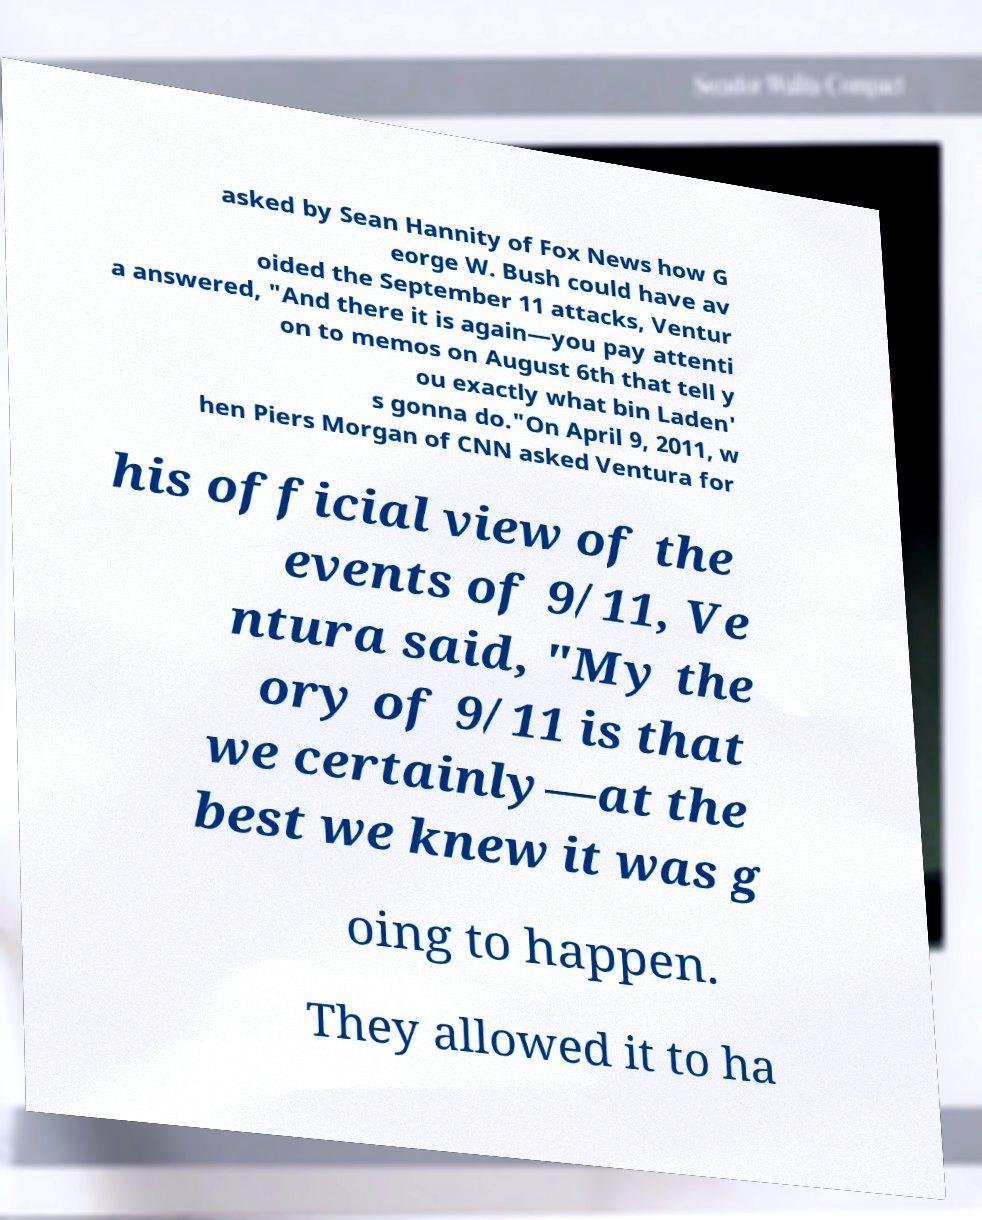For documentation purposes, I need the text within this image transcribed. Could you provide that? asked by Sean Hannity of Fox News how G eorge W. Bush could have av oided the September 11 attacks, Ventur a answered, "And there it is again—you pay attenti on to memos on August 6th that tell y ou exactly what bin Laden' s gonna do."On April 9, 2011, w hen Piers Morgan of CNN asked Ventura for his official view of the events of 9/11, Ve ntura said, "My the ory of 9/11 is that we certainly—at the best we knew it was g oing to happen. They allowed it to ha 